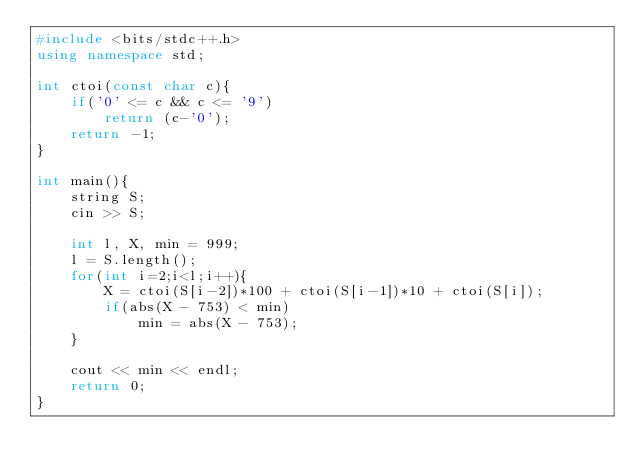Convert code to text. <code><loc_0><loc_0><loc_500><loc_500><_C++_>#include <bits/stdc++.h>
using namespace std;

int ctoi(const char c){
    if('0' <= c && c <= '9')
        return (c-'0');
    return -1;
}
 
int main(){
    string S;
    cin >> S;
    
    int l, X, min = 999;
    l = S.length();
    for(int i=2;i<l;i++){
        X = ctoi(S[i-2])*100 + ctoi(S[i-1])*10 + ctoi(S[i]);
        if(abs(X - 753) < min)
            min = abs(X - 753);
    }

    cout << min << endl;
    return 0;
}</code> 